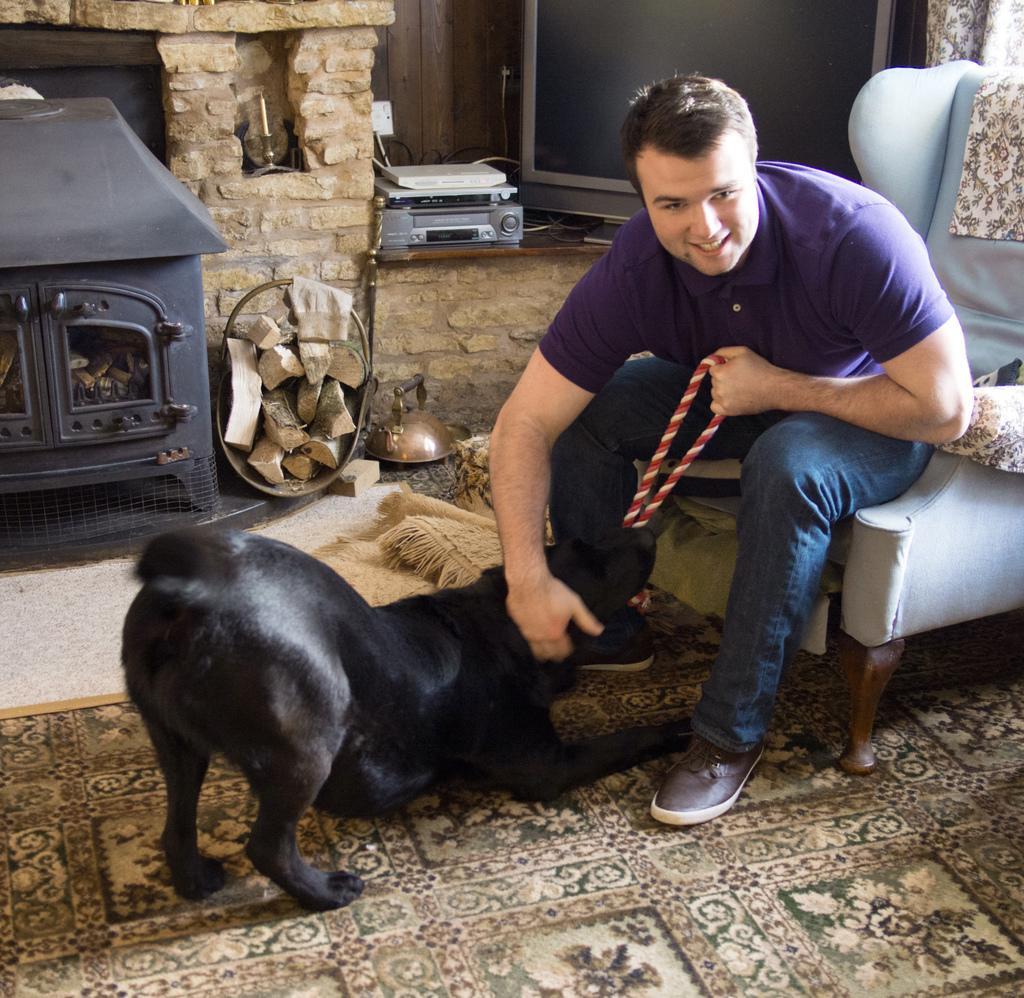How would you summarize this image in a sentence or two? In this picture we can see a man who is sitting on the chair. This is dog. On the background we can see a wall. This is television and this is floor. 